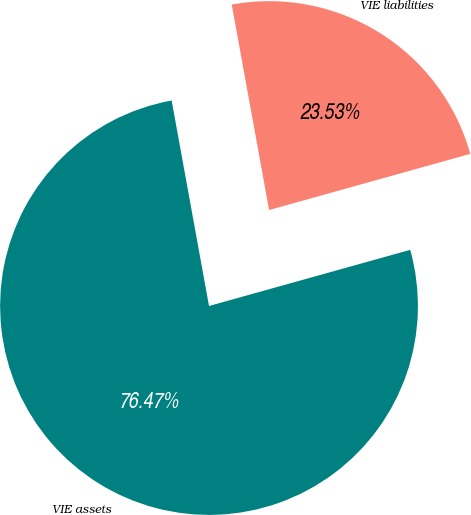Convert chart to OTSL. <chart><loc_0><loc_0><loc_500><loc_500><pie_chart><fcel>VIE assets<fcel>VIE liabilities<nl><fcel>76.47%<fcel>23.53%<nl></chart> 